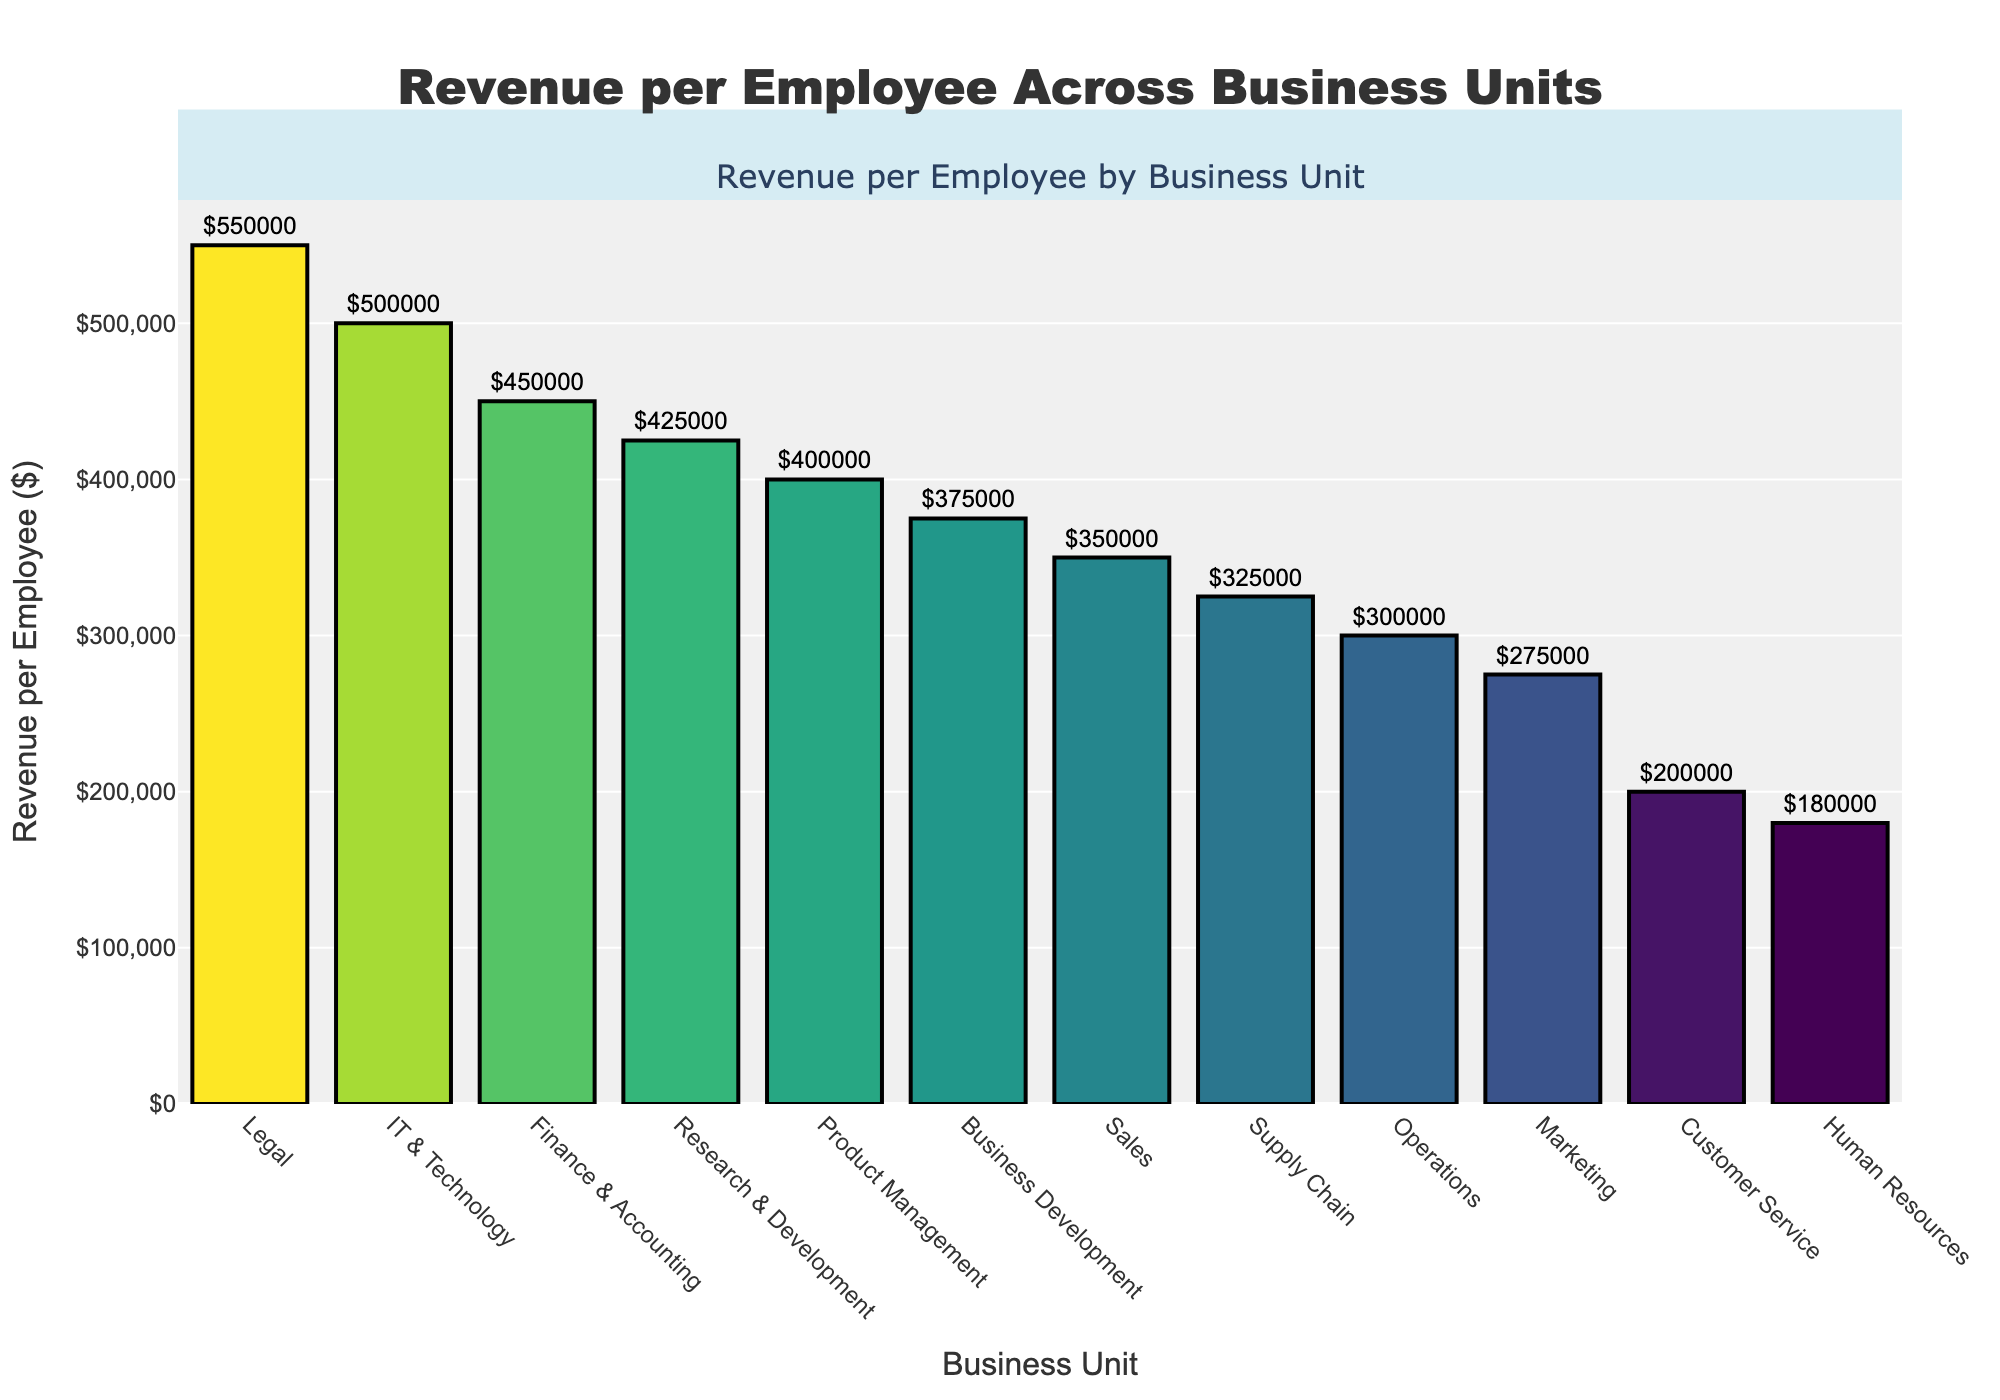What is the business unit with the highest revenue per employee? The highest bar in the chart corresponds to the business unit generating the most revenue per employee. Examining the chart, the tallest bar belongs to "Legal" with $550,000 revenue per employee.
Answer: Legal What is the difference in revenue per employee between IT & Technology and Customer Service? Locate the bars for IT & Technology and Customer Service. IT & Technology shows $500,000 while Customer Service shows $200,000. The difference is $500,000 - $200,000 = $300,000.
Answer: $300,000 Which business unit has a revenue per employee less than $200,000? Find the bar that is lower than the $200,000 mark. The only bar that fits this criterion is for "Human Resources" with a revenue per employee of $180,000.
Answer: Human Resources How many business units have a revenue per employee greater than $400,000? Count the number of bars higher than the $400,000 line. The business units are Legal ($550,000), IT & Technology ($500,000), Research & Development ($425,000), and Finance & Accounting ($450,000). There are 4 units.
Answer: 4 What is the average revenue per employee for Sales, Marketing, and Operations? Identify the revenue for each unit: Sales ($350,000), Marketing ($275,000), and Operations ($300,000). Sum them up: $350,000 + $275,000 + $300,000 = $925,000. Divide by 3: $925,000 / 3 = $308,333.33.
Answer: $308,333.33 What is the median revenue per employee across all business units? List all revenues and sort them: $180,000, $200,000, $275,000, $300,000, $325,000, $350,000, $375,000, $400,000, $425,000, $450,000, $500,000, $550,000. Since there are 12 values, the median is the average of the 6th and 7th values: ($350,000 + $375,000) / 2 = $362,500.
Answer: $362,500 Which two business units have the closest revenue per employee? Compare adjacent revenue values in the sorted list and find the smallest difference. "Sales" ($350,000) and "Supply Chain" ($325,000) have a difference of $350,000 - $325,000 = $25,000, which is the smallest.
Answer: Sales and Supply Chain Are there any business units where the revenue per employee is between $300,000 and $400,000? Find bars where the revenue falls within this range. These units are Sales ($350,000), Operations ($300,000), Supply Chain ($325,000), Product Management ($400,000), and Business Development ($375,000).
Answer: Yes 